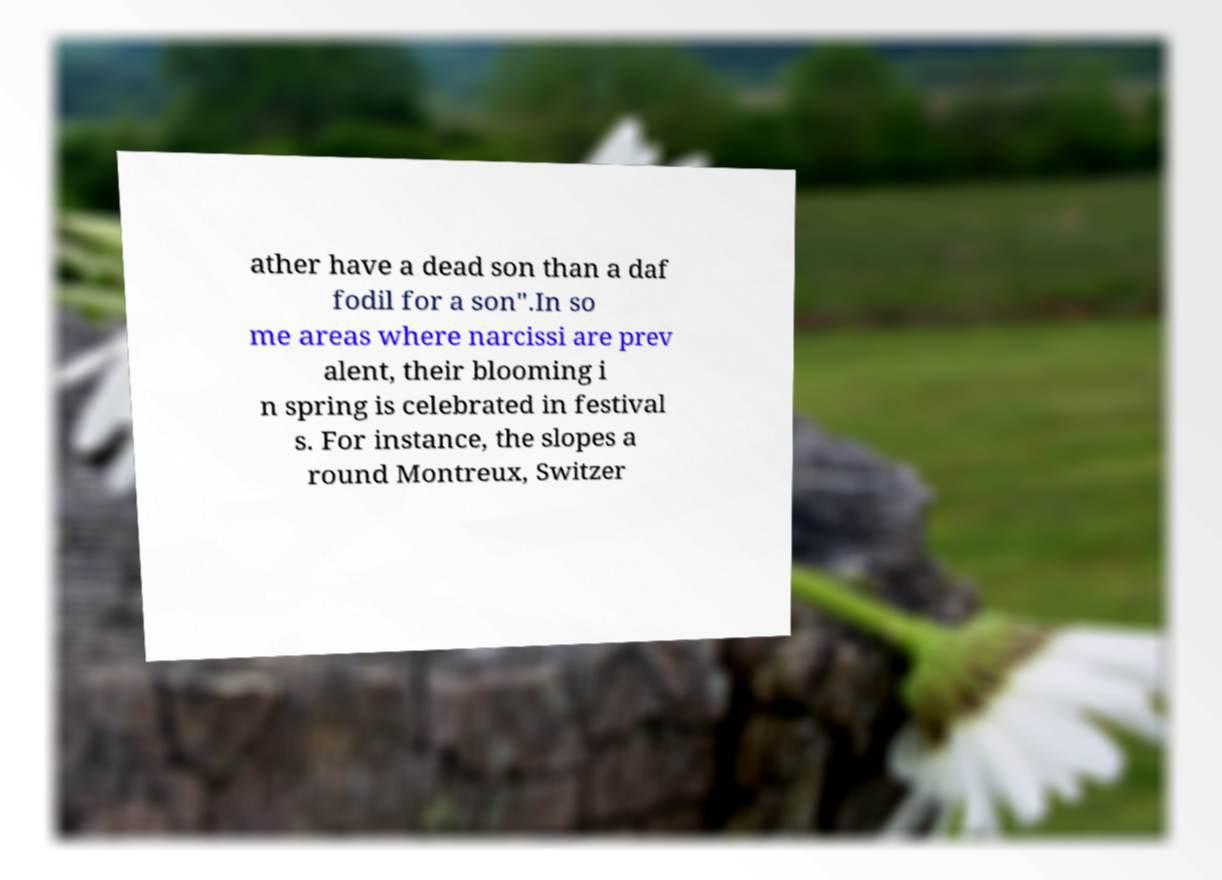Could you extract and type out the text from this image? ather have a dead son than a daf fodil for a son".In so me areas where narcissi are prev alent, their blooming i n spring is celebrated in festival s. For instance, the slopes a round Montreux, Switzer 